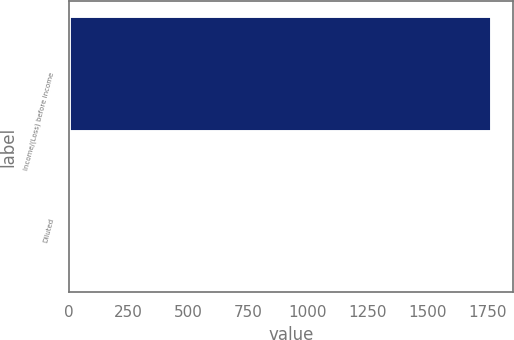Convert chart to OTSL. <chart><loc_0><loc_0><loc_500><loc_500><bar_chart><fcel>Income/(Loss) before income<fcel>Diluted<nl><fcel>1770<fcel>0.39<nl></chart> 